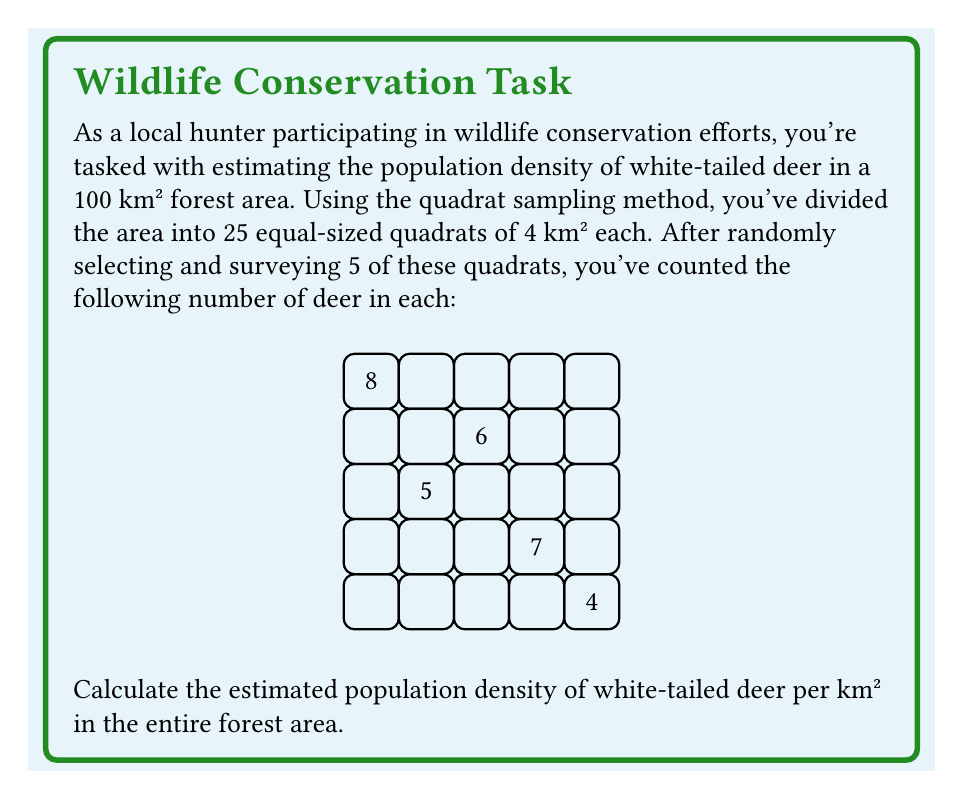What is the answer to this math problem? To solve this problem, we'll follow these steps:

1) First, calculate the total number of deer counted in the sampled quadrats:
   $$8 + 6 + 5 + 7 + 4 = 30$$ deer

2) Calculate the total area sampled:
   $$5 \text{ quadrats} \times 4 \text{ km²/quadrat} = 20 \text{ km²}$$

3) Calculate the density in the sampled area:
   $$\text{Density} = \frac{\text{Number of deer}}{\text{Area sampled}} = \frac{30 \text{ deer}}{20 \text{ km²}} = 1.5 \text{ deer/km²}$$

4) Assuming this density is representative of the entire forest, we can estimate the total population:
   $$\text{Estimated total population} = \text{Density} \times \text{Total area}$$
   $$= 1.5 \text{ deer/km²} \times 100 \text{ km²} = 150 \text{ deer}$$

5) The population density for the entire forest area is the same as the density in the sampled area:
   $$1.5 \text{ deer/km²}$$

This method assumes that the randomly selected quadrats are representative of the entire area, which is a key principle in spatial sampling techniques.
Answer: $1.5 \text{ deer/km²}$ 